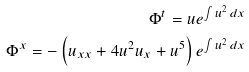<formula> <loc_0><loc_0><loc_500><loc_500>\Phi ^ { t } = u e ^ { \int u ^ { 2 } \, d x } \\ \Phi ^ { x } = - \left ( u _ { x x } + 4 u ^ { 2 } u _ { x } + u ^ { 5 } \right ) e ^ { \int u ^ { 2 } \, d x }</formula> 